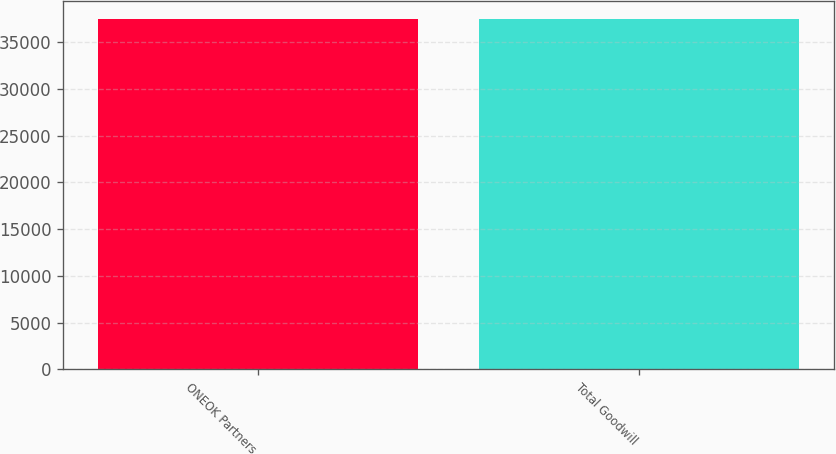Convert chart to OTSL. <chart><loc_0><loc_0><loc_500><loc_500><bar_chart><fcel>ONEOK Partners<fcel>Total Goodwill<nl><fcel>37489<fcel>37489.1<nl></chart> 